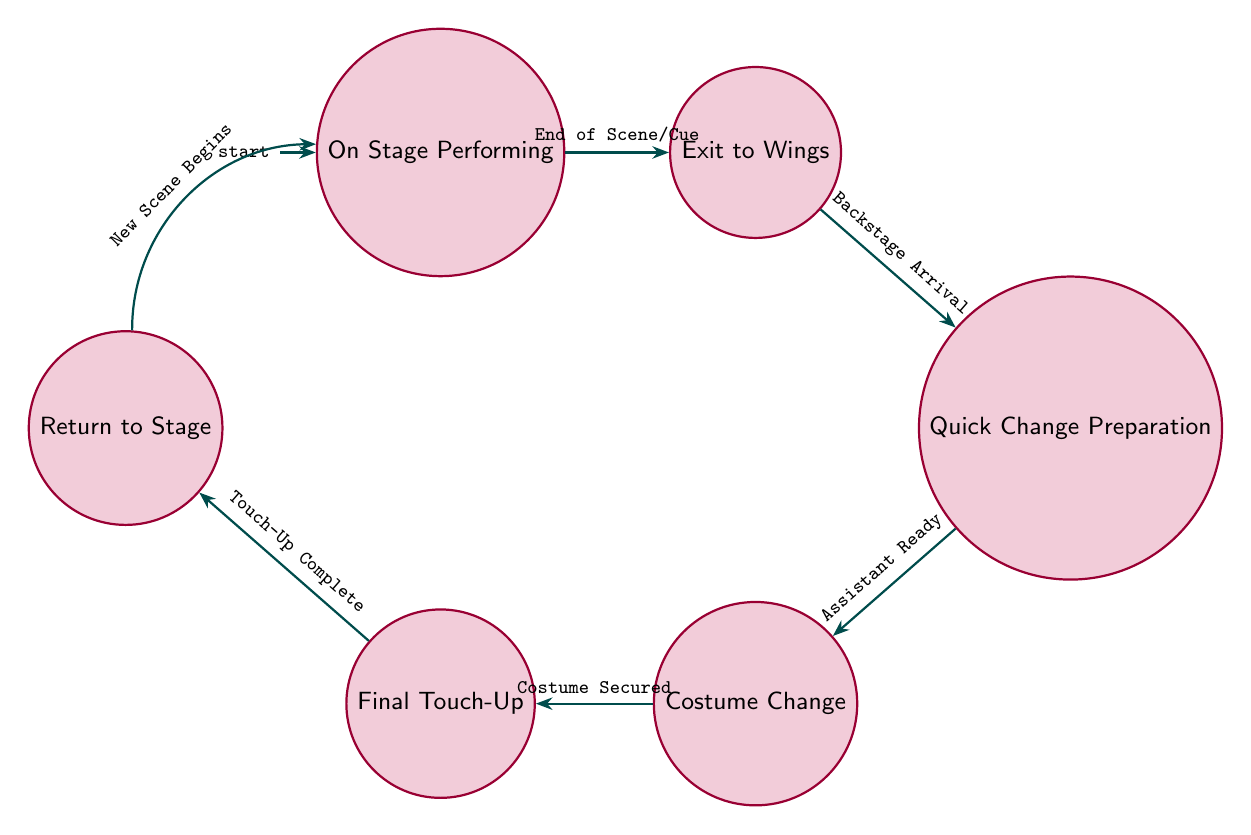What's the starting state in the diagram? The diagram indicates that the initial state is labeled "On Stage Performing," which is represented as the starting point for the transitions.
Answer: On Stage Performing How many nodes are there in total? Counting through the states shown in the diagram, there are six distinct nodes listed, corresponding to different phases in the costume change sequence.
Answer: 6 What is the transition from "Quick Change Preparation" to "Costume Change" triggered by? The transition from "Quick Change Preparation" to "Costume Change" occurs when the assistant is ready and the new costume is ready, as stated in the diagram.
Answer: Assistant Ready/New Costume Ready How does one return to "On Stage Performing" after "Final Touch-Up"? To return to "On Stage Performing" after "Final Touch-Up," the transition is triggered when the touch-up is complete and the next cue is ready, indicating readiness to return to the performance.
Answer: Touch-Up Complete/Next Cue What is the sequence of states starting from "On Stage Performing"? The sequence begins at "On Stage Performing," then transitions to "Exit to Wings," moves to "Quick Change Preparation," progresses to "Costume Change," leads into "Final Touch-Up," and finally reaches "Return to Stage."
Answer: On Stage Performing, Exit to Wings, Quick Change Preparation, Costume Change, Final Touch-Up, Return to Stage Which two states have a transition labeled "Costume Secured"? The states that have a transition labeled "Costume Secured" are "Costume Change" and "Final Touch-Up," indicating the sequence of operations in the costume change process.
Answer: Costume Change, Final Touch-Up What starts the transition between "On Stage Performing" and "Exit to Wings"? The transition between "On Stage Performing" and "Exit to Wings" is initiated by the end of a scene or cue, prompting the performer to exit for a costume change.
Answer: End of Scene/Cue What state comes immediately after "Costume Change"? The state that comes immediately after "Costume Change" in the sequence is "Final Touch-Up," indicating that the final adjustments to the costume are made following the change.
Answer: Final Touch-Up What triggers the transition from "Final Touch-Up" to "Return to Stage"? The transition from "Final Touch-Up" to "Return to Stage" is triggered by either the completion of the touch-up or the approach of the next cue, signaling it is time to return to the stage.
Answer: Touch-Up Complete/Next Cue 